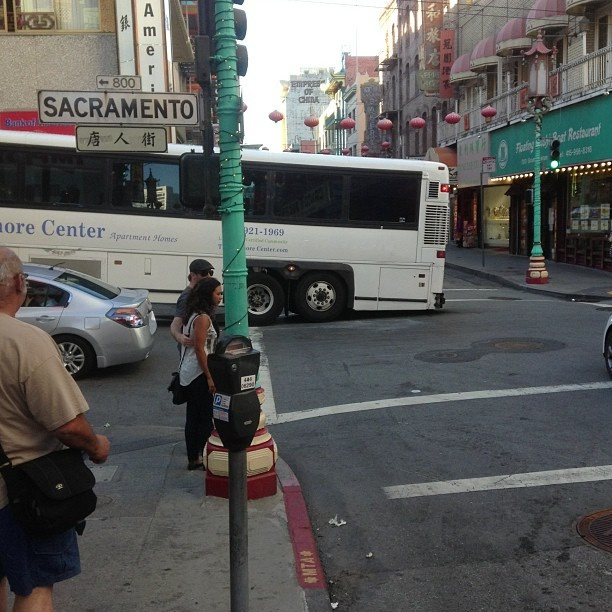Describe the objects in this image and their specific colors. I can see bus in black, darkgray, gray, and lightgray tones, people in black, gray, and maroon tones, car in black, gray, and darkgray tones, handbag in black, gray, and maroon tones, and people in black, gray, maroon, and brown tones in this image. 